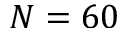<formula> <loc_0><loc_0><loc_500><loc_500>N = 6 0</formula> 